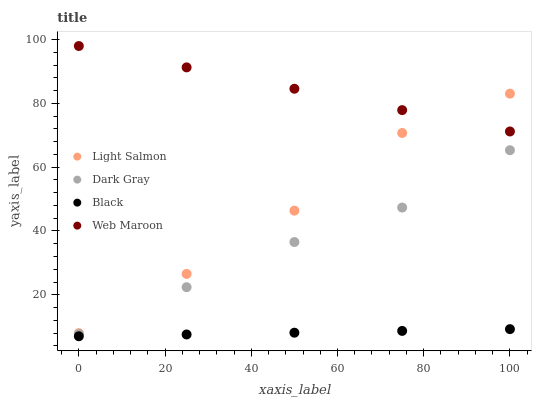Does Black have the minimum area under the curve?
Answer yes or no. Yes. Does Web Maroon have the maximum area under the curve?
Answer yes or no. Yes. Does Light Salmon have the minimum area under the curve?
Answer yes or no. No. Does Light Salmon have the maximum area under the curve?
Answer yes or no. No. Is Black the smoothest?
Answer yes or no. Yes. Is Light Salmon the roughest?
Answer yes or no. Yes. Is Web Maroon the smoothest?
Answer yes or no. No. Is Web Maroon the roughest?
Answer yes or no. No. Does Black have the lowest value?
Answer yes or no. Yes. Does Light Salmon have the lowest value?
Answer yes or no. No. Does Web Maroon have the highest value?
Answer yes or no. Yes. Does Light Salmon have the highest value?
Answer yes or no. No. Is Dark Gray less than Light Salmon?
Answer yes or no. Yes. Is Dark Gray greater than Black?
Answer yes or no. Yes. Does Web Maroon intersect Light Salmon?
Answer yes or no. Yes. Is Web Maroon less than Light Salmon?
Answer yes or no. No. Is Web Maroon greater than Light Salmon?
Answer yes or no. No. Does Dark Gray intersect Light Salmon?
Answer yes or no. No. 